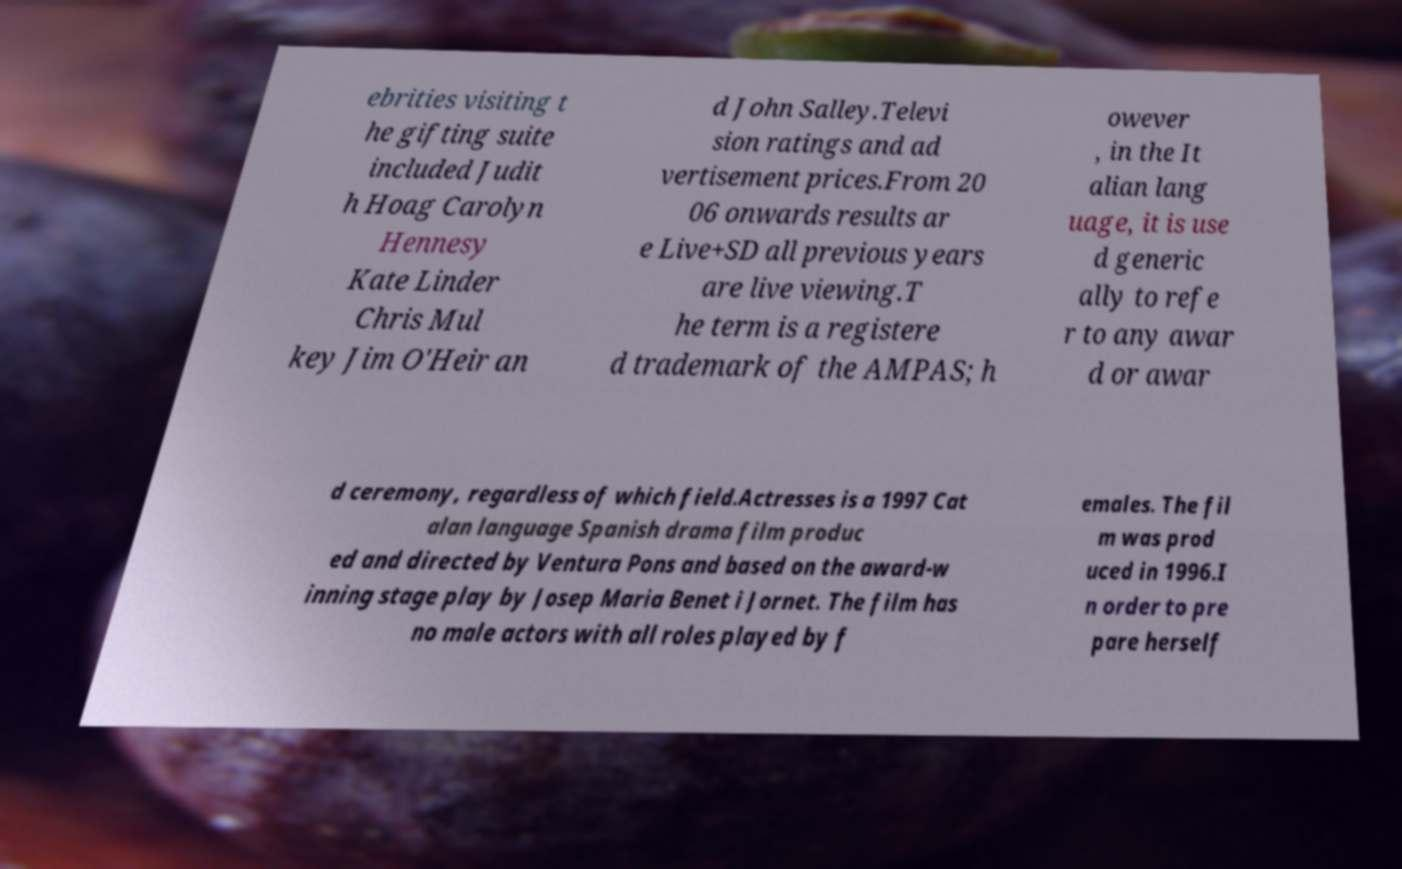I need the written content from this picture converted into text. Can you do that? ebrities visiting t he gifting suite included Judit h Hoag Carolyn Hennesy Kate Linder Chris Mul key Jim O'Heir an d John Salley.Televi sion ratings and ad vertisement prices.From 20 06 onwards results ar e Live+SD all previous years are live viewing.T he term is a registere d trademark of the AMPAS; h owever , in the It alian lang uage, it is use d generic ally to refe r to any awar d or awar d ceremony, regardless of which field.Actresses is a 1997 Cat alan language Spanish drama film produc ed and directed by Ventura Pons and based on the award-w inning stage play by Josep Maria Benet i Jornet. The film has no male actors with all roles played by f emales. The fil m was prod uced in 1996.I n order to pre pare herself 